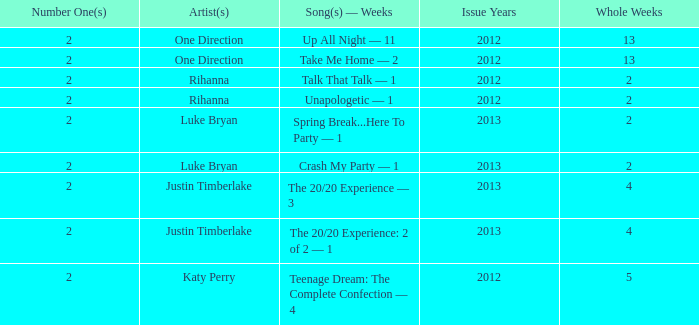What is the name of each track, and the number of weeks it held the #1 position for rihanna in 2012? Talk That Talk — 1, Unapologetic — 1. 